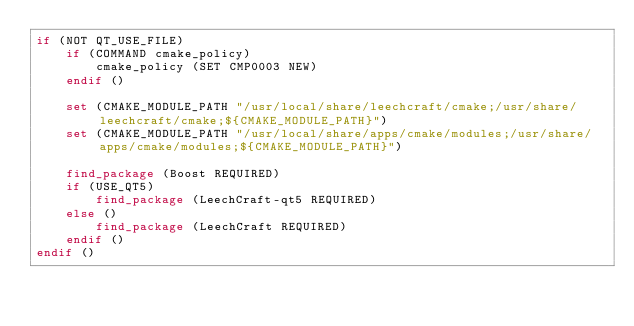Convert code to text. <code><loc_0><loc_0><loc_500><loc_500><_CMake_>if (NOT QT_USE_FILE)
	if (COMMAND cmake_policy)
		cmake_policy (SET CMP0003 NEW)
	endif ()

	set (CMAKE_MODULE_PATH "/usr/local/share/leechcraft/cmake;/usr/share/leechcraft/cmake;${CMAKE_MODULE_PATH}")
	set (CMAKE_MODULE_PATH "/usr/local/share/apps/cmake/modules;/usr/share/apps/cmake/modules;${CMAKE_MODULE_PATH}")

	find_package (Boost REQUIRED)
	if (USE_QT5)
		find_package (LeechCraft-qt5 REQUIRED)
	else ()
		find_package (LeechCraft REQUIRED)
	endif ()
endif ()
</code> 